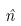<formula> <loc_0><loc_0><loc_500><loc_500>\hat { n }</formula> 